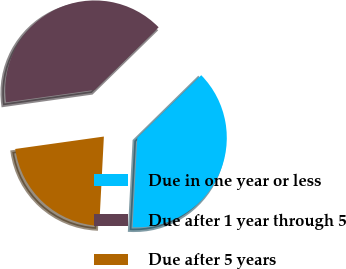Convert chart to OTSL. <chart><loc_0><loc_0><loc_500><loc_500><pie_chart><fcel>Due in one year or less<fcel>Due after 1 year through 5<fcel>Due after 5 years<nl><fcel>38.16%<fcel>39.88%<fcel>21.96%<nl></chart> 